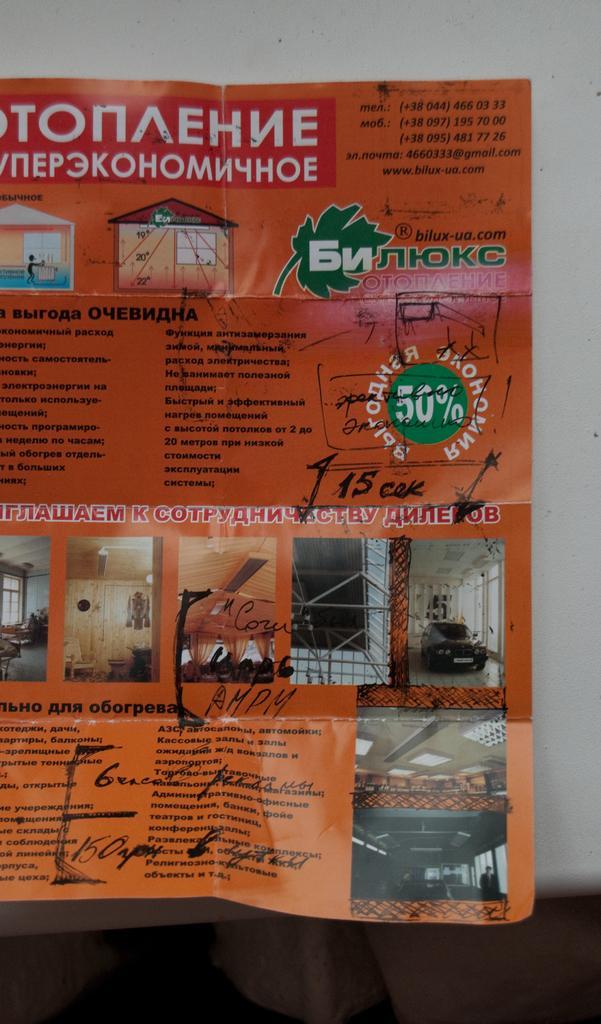Please provide a concise description of this image. In this image we can see a pamphlet, with some images, and texts written on it. 